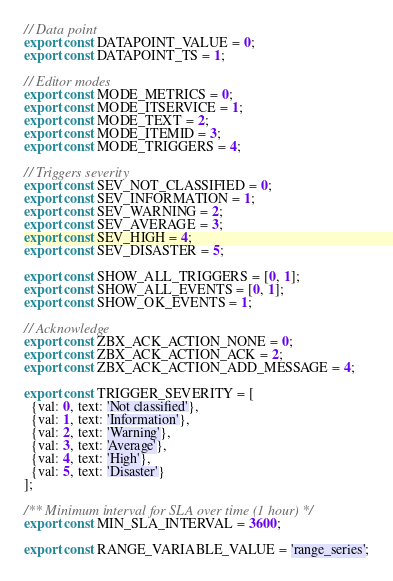<code> <loc_0><loc_0><loc_500><loc_500><_JavaScript_>// Data point
export const DATAPOINT_VALUE = 0;
export const DATAPOINT_TS = 1;

// Editor modes
export const MODE_METRICS = 0;
export const MODE_ITSERVICE = 1;
export const MODE_TEXT = 2;
export const MODE_ITEMID = 3;
export const MODE_TRIGGERS = 4;

// Triggers severity
export const SEV_NOT_CLASSIFIED = 0;
export const SEV_INFORMATION = 1;
export const SEV_WARNING = 2;
export const SEV_AVERAGE = 3;
export const SEV_HIGH = 4;
export const SEV_DISASTER = 5;

export const SHOW_ALL_TRIGGERS = [0, 1];
export const SHOW_ALL_EVENTS = [0, 1];
export const SHOW_OK_EVENTS = 1;

// Acknowledge
export const ZBX_ACK_ACTION_NONE = 0;
export const ZBX_ACK_ACTION_ACK = 2;
export const ZBX_ACK_ACTION_ADD_MESSAGE = 4;

export const TRIGGER_SEVERITY = [
  {val: 0, text: 'Not classified'},
  {val: 1, text: 'Information'},
  {val: 2, text: 'Warning'},
  {val: 3, text: 'Average'},
  {val: 4, text: 'High'},
  {val: 5, text: 'Disaster'}
];

/** Minimum interval for SLA over time (1 hour) */
export const MIN_SLA_INTERVAL = 3600;

export const RANGE_VARIABLE_VALUE = 'range_series';
</code> 